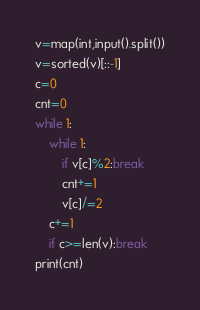<code> <loc_0><loc_0><loc_500><loc_500><_Python_>v=map(int,input().split())
v=sorted(v)[::-1]
c=0
cnt=0
while 1:
    while 1:
        if v[c]%2:break
        cnt+=1
        v[c]/=2
    c+=1 
    if c>=len(v):break
print(cnt)
</code> 